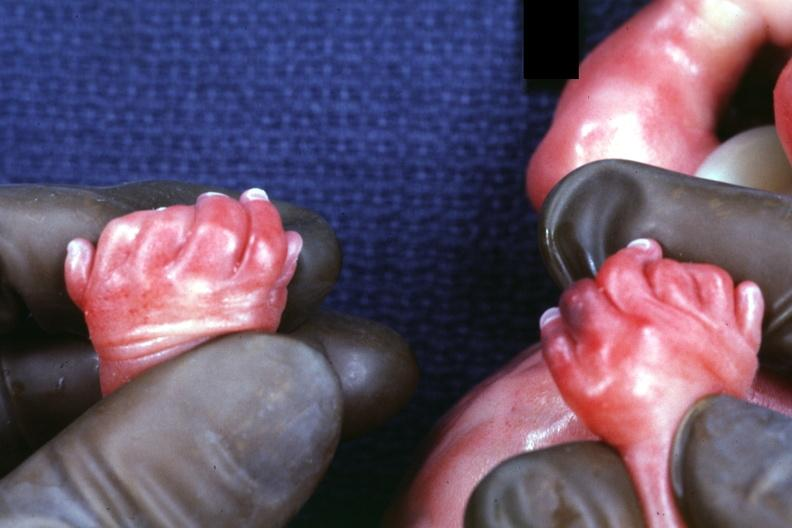what is present?
Answer the question using a single word or phrase. Six digits and syndactyly 